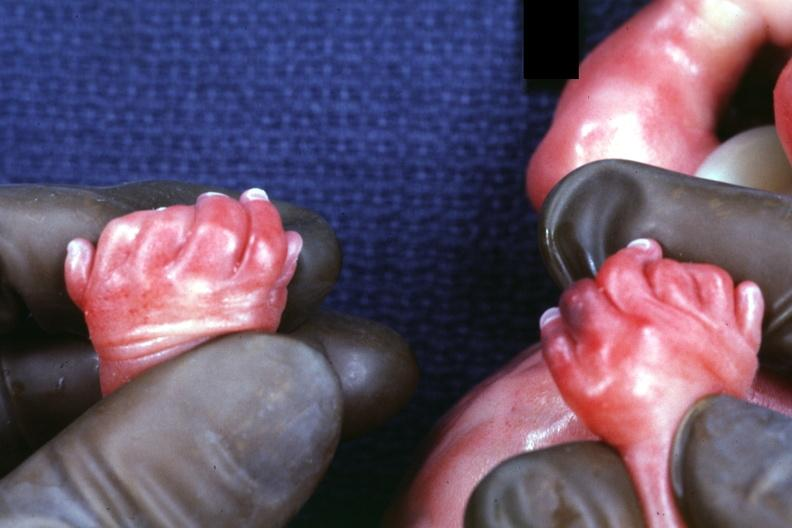what is present?
Answer the question using a single word or phrase. Six digits and syndactyly 